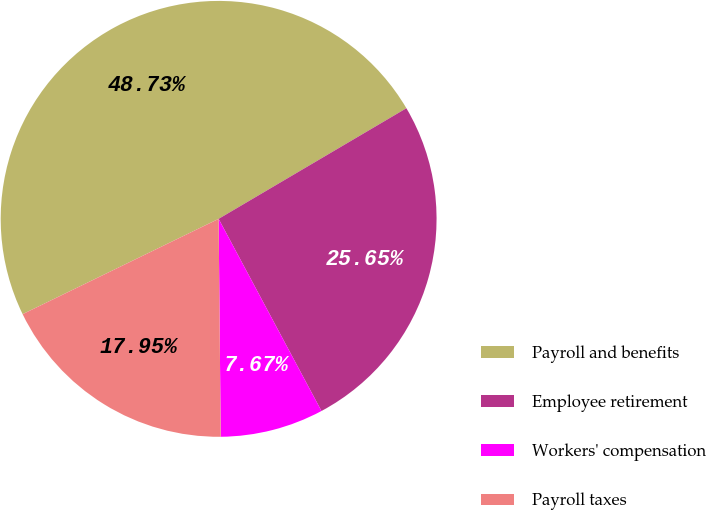Convert chart to OTSL. <chart><loc_0><loc_0><loc_500><loc_500><pie_chart><fcel>Payroll and benefits<fcel>Employee retirement<fcel>Workers' compensation<fcel>Payroll taxes<nl><fcel>48.73%<fcel>25.65%<fcel>7.67%<fcel>17.95%<nl></chart> 